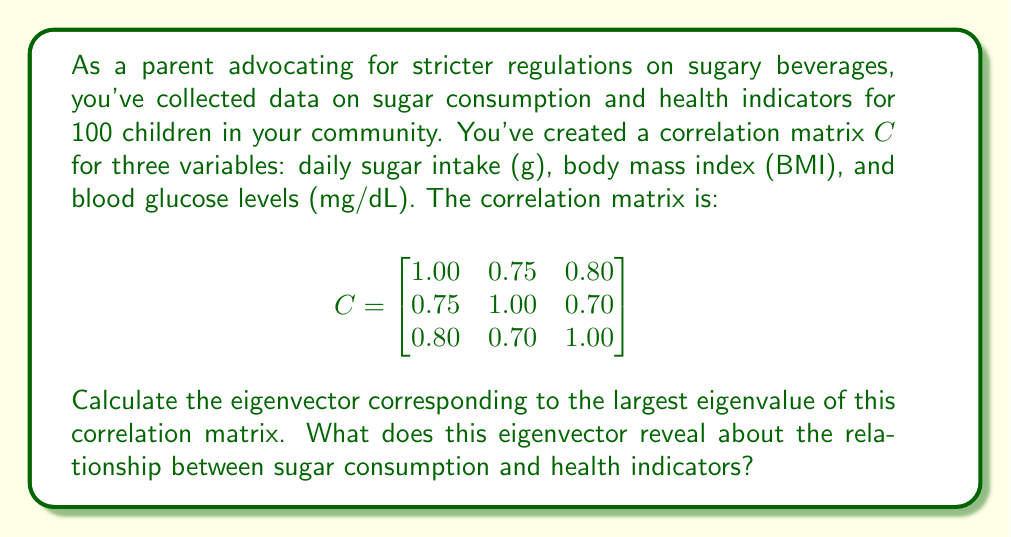Can you answer this question? To solve this problem, we'll follow these steps:

1) First, we need to find the eigenvalues of the correlation matrix $C$. The characteristic equation is:

   $\det(C - \lambda I) = 0$

   $$\begin{vmatrix}
   1.00 - \lambda & 0.75 & 0.80 \\
   0.75 & 1.00 - \lambda & 0.70 \\
   0.80 & 0.70 & 1.00 - \lambda
   \end{vmatrix} = 0$$

2) Expanding this determinant gives us the cubic equation:

   $-\lambda^3 + 3\lambda^2 - 0.7625\lambda - 0.5125 = 0$

3) Solving this equation (using numerical methods) gives us the eigenvalues:
   $\lambda_1 \approx 2.4839$, $\lambda_2 \approx 0.3161$, $\lambda_3 \approx 0.2000$

4) The largest eigenvalue is $\lambda_1 \approx 2.4839$. Now we need to find the corresponding eigenvector.

5) We solve the equation $(C - \lambda_1 I)v = 0$:

   $$\begin{bmatrix}
   -1.4839 & 0.75 & 0.80 \\
   0.75 & -1.4839 & 0.70 \\
   0.80 & 0.70 & -1.4839
   \end{bmatrix} \begin{bmatrix} v_1 \\ v_2 \\ v_3 \end{bmatrix} = \begin{bmatrix} 0 \\ 0 \\ 0 \end{bmatrix}$$

6) Solving this system of equations (and normalizing the result) gives us the eigenvector:

   $v \approx \begin{bmatrix} 0.5916 \\ 0.5647 \\ 0.5754 \end{bmatrix}$

7) This eigenvector represents the direction of maximum variance in the data. The components of this vector show how each variable contributes to this principal direction.

8) We can interpret this result as follows:
   - All components are positive and of similar magnitude, indicating that all three variables (sugar intake, BMI, and blood glucose) are positively correlated and contribute similarly to the main trend in the data.
   - The slightly larger value for sugar intake (0.5916) suggests that it has a slightly stronger influence on this principal component.
   - This aligns with the correlation matrix, which showed strong positive correlations between all variables, with sugar intake having the strongest correlations overall.
Answer: The eigenvector corresponding to the largest eigenvalue is approximately $\begin{bmatrix} 0.5916 \\ 0.5647 \\ 0.5754 \end{bmatrix}$. This reveals that sugar consumption, BMI, and blood glucose levels are all strongly and positively correlated, with sugar intake having a slightly stronger influence on the overall health trend. This supports the argument for stricter regulations on sugary beverages and snacks, as sugar intake appears to be closely linked to important health indicators. 